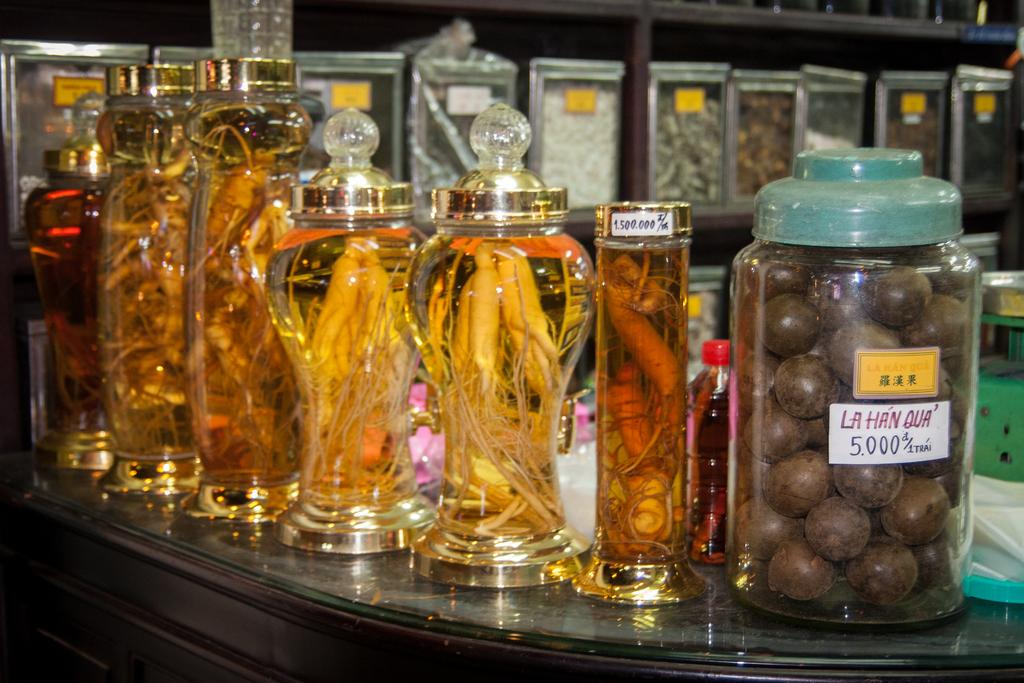<image>
Share a concise interpretation of the image provided. Several items are in jars lined up on a counter, including a jar that says La Han Qua. 